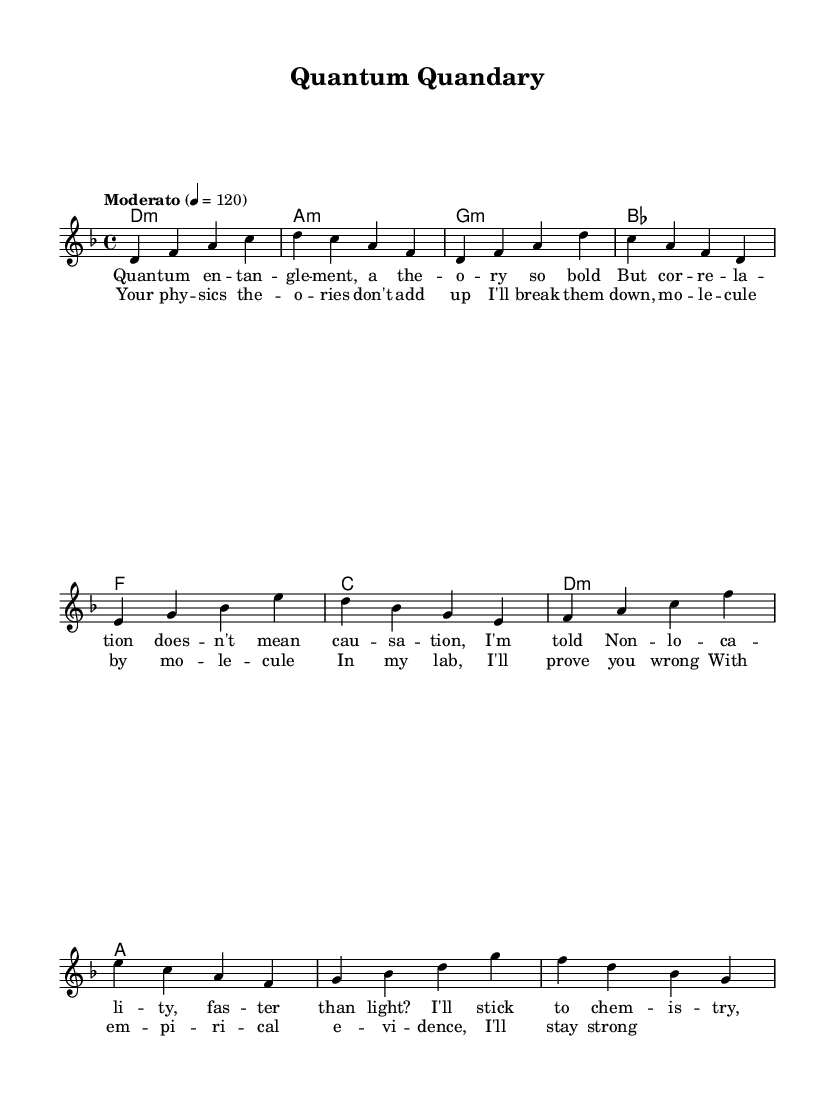What is the key signature of this music? The key signature is indicated by the number of sharps or flats in the beginning of the staff. In this case, there are no sharps or flats shown, which corresponds to D minor.
Answer: D minor What is the time signature of this music? The time signature can be found at the beginning of the piece, where it shows how many beats are in each measure. Here, it displays "4/4", indicating there are four beats per measure.
Answer: 4/4 What is the tempo marking of this piece? The tempo marking is typically placed above the staff and indicates the speed of the music. In this instance, it is shown as "Moderato" followed by a metronome marking of 120 beats per minute.
Answer: Moderato 4 = 120 How many measures are in the verse section? The verse section is identified by the lyrics and can be counted by identifying the measures in the music notation. The verse consists of four measures in total as evidenced by the lyrics placed under them.
Answer: 4 What chord does the song start with? The first chord is indicated in the chord changes section at the start of the music to the left of the staff. The first chord is labeled as "d:min" which represents D minor.
Answer: d:min What is the last lyric line of the chorus? The last lyric line can be found in the chorus section when examining the lyrics written beneath the melody notes in the music. The final line states "With empirical evidence, I'll stay strong."
Answer: With empirical evidence, I'll stay strong What is the relationship between the verses and the chorus? The verses and chorus can be analyzed for their thematic connection. The verses challenge the validity of physics theories, while the chorus emphasizes the singer's commitment to using empirical evidence from biochemistry to debunk these theories, showing a direct contrast.
Answer: Challenge vs. commitment 